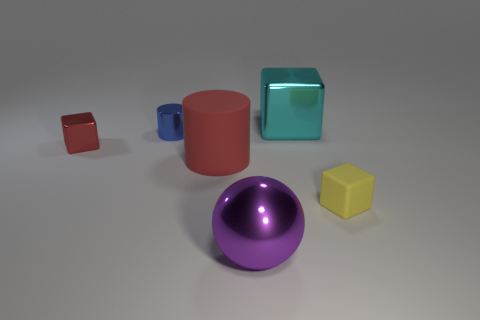Subtract all blue blocks. Subtract all blue balls. How many blocks are left? 3 Add 2 spheres. How many objects exist? 8 Subtract all cylinders. How many objects are left? 4 Add 3 large shiny blocks. How many large shiny blocks exist? 4 Subtract 1 cyan blocks. How many objects are left? 5 Subtract all cyan metal things. Subtract all cyan metallic blocks. How many objects are left? 4 Add 3 red objects. How many red objects are left? 5 